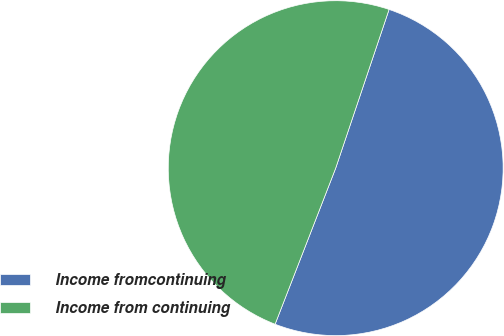Convert chart. <chart><loc_0><loc_0><loc_500><loc_500><pie_chart><fcel>Income fromcontinuing<fcel>Income from continuing<nl><fcel>50.73%<fcel>49.27%<nl></chart> 